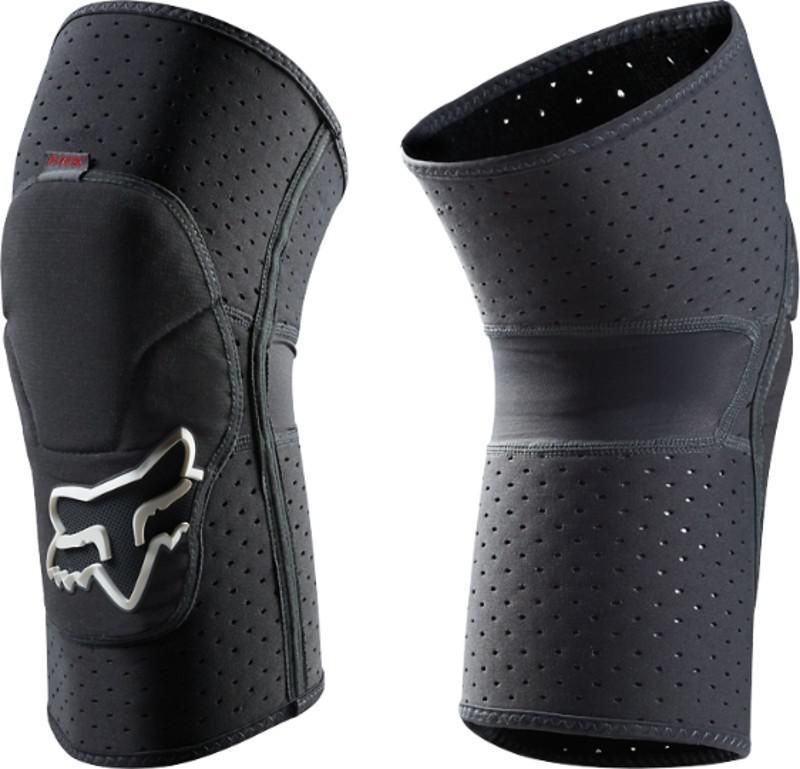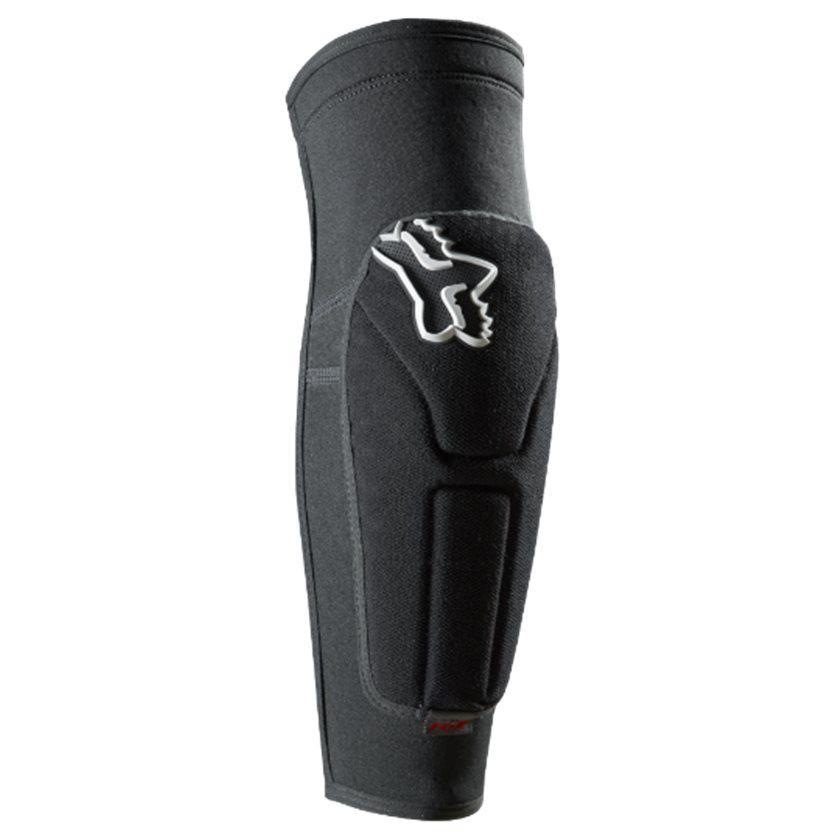The first image is the image on the left, the second image is the image on the right. For the images shown, is this caption "All of the images contain only one knee guard." true? Answer yes or no. No. 